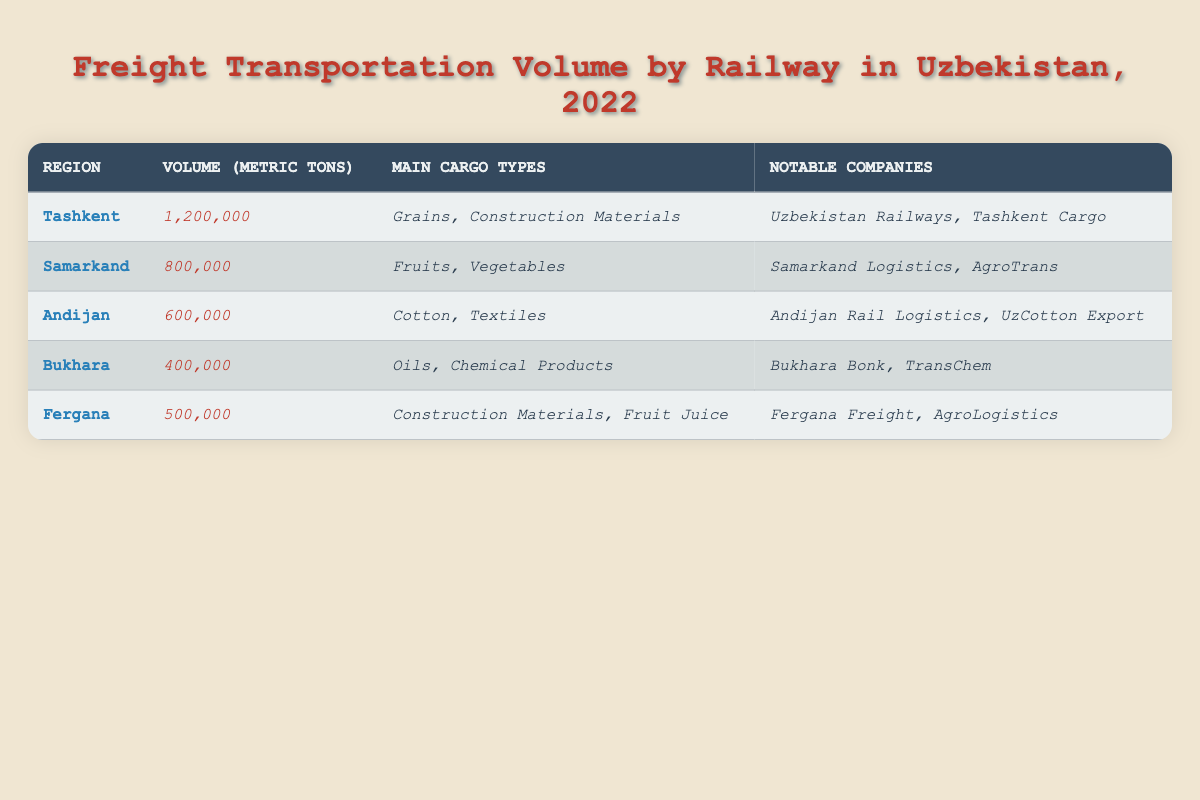What is the total freight transportation volume in Uzbekistan for the year 2022? To find the total volume, I'll sum the volumes from all regions: 1,200,000 (Tashkent) + 800,000 (Samarkand) + 600,000 (Andijan) + 400,000 (Bukhara) + 500,000 (Fergana) = 3,500,000 metric tons.
Answer: 3,500,000 metric tons Which region has the highest freight transportation volume? From the table, Tashkent has the highest volume of 1,200,000 metric tons compared to other regions.
Answer: Tashkent How many metric tons of freight were transported in Fergana? The volume of freight transported in Fergana is explicitly listed in the table as 500,000 metric tons.
Answer: 500,000 metric tons What were the main cargo types transported in Samarkand? The table lists the main cargo types for Samarkand as Fruits and Vegetables.
Answer: Fruits, Vegetables Is it true that Andijan transports more volume than Bukhara? Yes, comparing the volumes, Andijan has 600,000 metric tons while Bukhara only has 400,000 metric tons, confirming that Andijan transports more.
Answer: Yes Which region has the least freight transportation volume, and what is the volume? Bukhara has the least freight transportation volume, which is 400,000 metric tons as per the table data.
Answer: Bukhara, 400,000 metric tons What is the combined volume of freight transportation for Tashkent and Samarkand? I will add the volumes from Tashkent (1,200,000 metric tons) and Samarkand (800,000 metric tons): 1,200,000 + 800,000 = 2,000,000 metric tons.
Answer: 2,000,000 metric tons Which notable companies are associated with Andijan's freight transport? The table indicates that Andijan's notable companies are Andijan Rail Logistics and UzCotton Export.
Answer: Andijan Rail Logistics, UzCotton Export If we rank the regions by volume, what would be the second highest? The second highest region, after Tashkent, is Samarkand with a volume of 800,000 metric tons.
Answer: Samarkand How many different types of cargo are listed for Tashkent? The table shows that there are two types of cargo listed for Tashkent: Grains and Construction Materials.
Answer: 2 types of cargo 